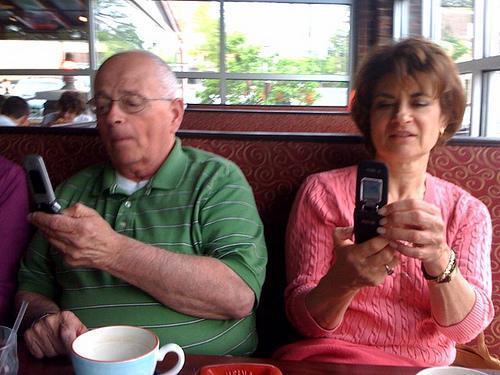How many people are looking at cellphones in the picture?
Give a very brief answer. 2. 